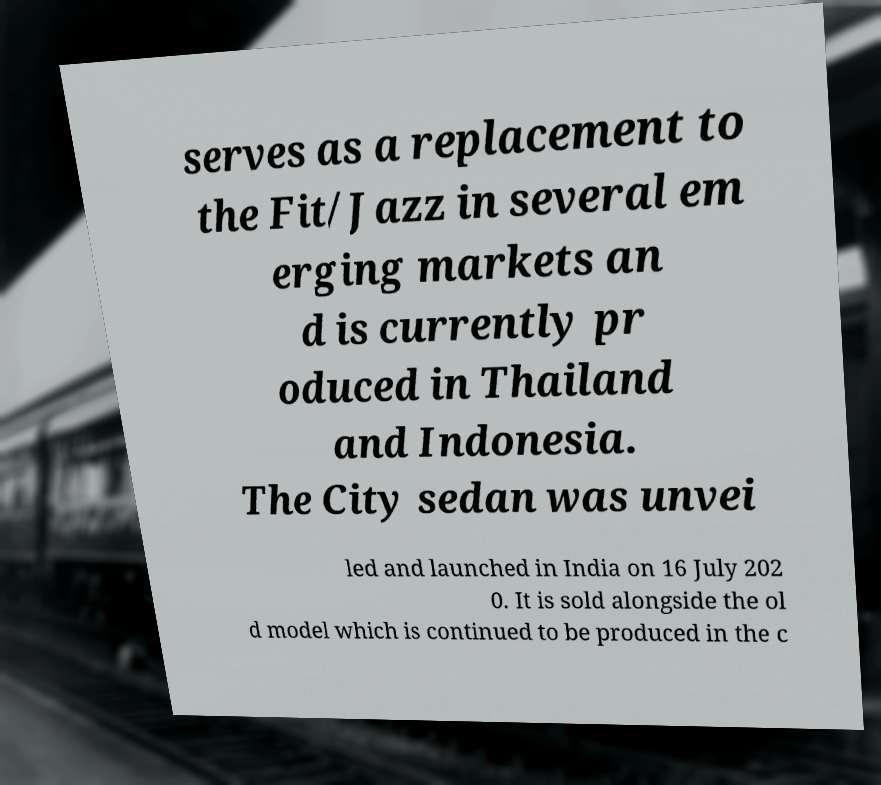Please identify and transcribe the text found in this image. serves as a replacement to the Fit/Jazz in several em erging markets an d is currently pr oduced in Thailand and Indonesia. The City sedan was unvei led and launched in India on 16 July 202 0. It is sold alongside the ol d model which is continued to be produced in the c 